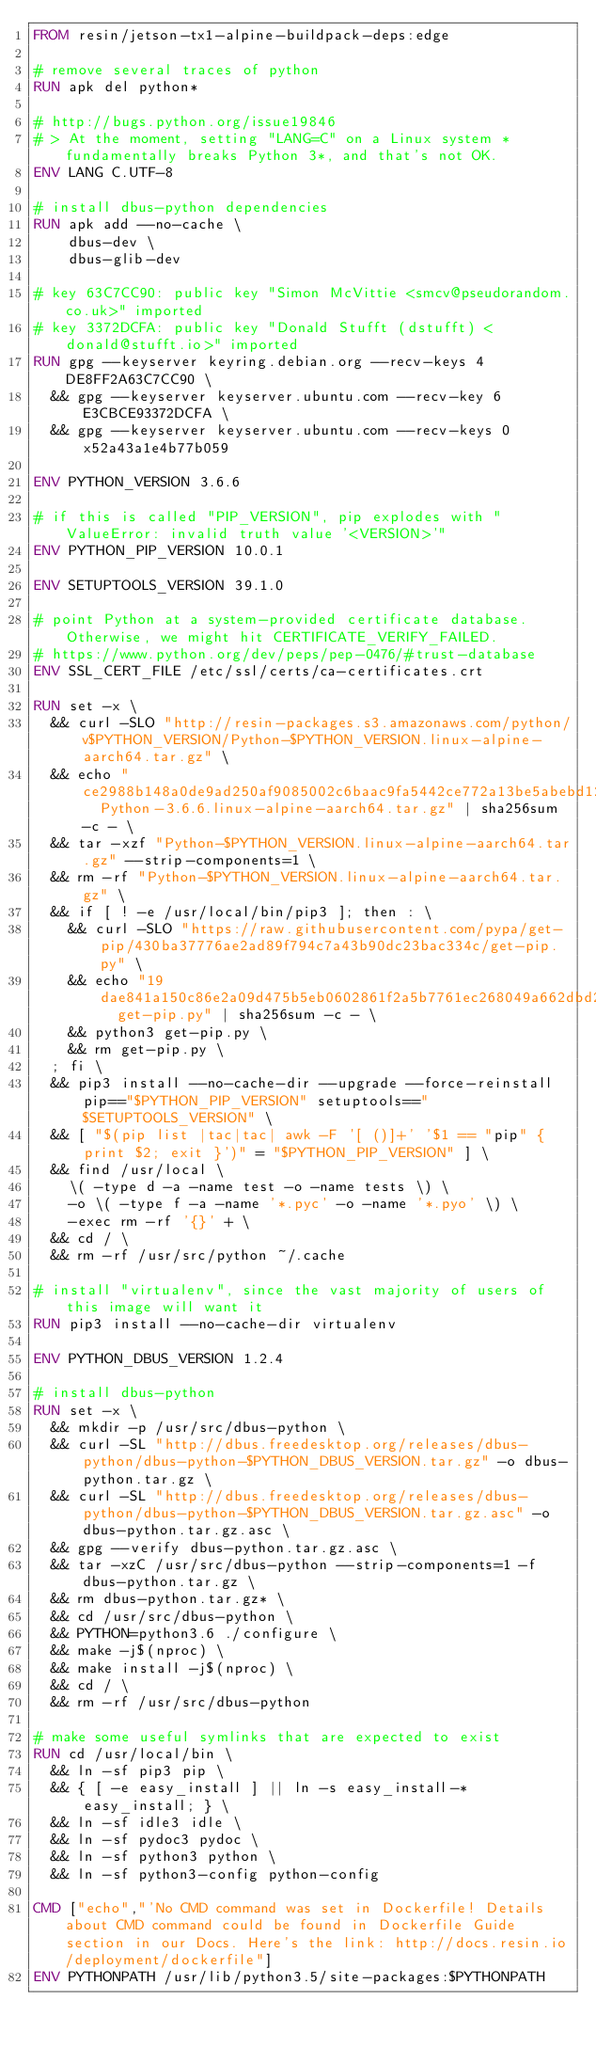Convert code to text. <code><loc_0><loc_0><loc_500><loc_500><_Dockerfile_>FROM resin/jetson-tx1-alpine-buildpack-deps:edge

# remove several traces of python
RUN apk del python*

# http://bugs.python.org/issue19846
# > At the moment, setting "LANG=C" on a Linux system *fundamentally breaks Python 3*, and that's not OK.
ENV LANG C.UTF-8

# install dbus-python dependencies 
RUN apk add --no-cache \
		dbus-dev \
		dbus-glib-dev

# key 63C7CC90: public key "Simon McVittie <smcv@pseudorandom.co.uk>" imported
# key 3372DCFA: public key "Donald Stufft (dstufft) <donald@stufft.io>" imported
RUN gpg --keyserver keyring.debian.org --recv-keys 4DE8FF2A63C7CC90 \
	&& gpg --keyserver keyserver.ubuntu.com --recv-key 6E3CBCE93372DCFA \
	&& gpg --keyserver keyserver.ubuntu.com --recv-keys 0x52a43a1e4b77b059

ENV PYTHON_VERSION 3.6.6

# if this is called "PIP_VERSION", pip explodes with "ValueError: invalid truth value '<VERSION>'"
ENV PYTHON_PIP_VERSION 10.0.1

ENV SETUPTOOLS_VERSION 39.1.0

# point Python at a system-provided certificate database. Otherwise, we might hit CERTIFICATE_VERIFY_FAILED.
# https://www.python.org/dev/peps/pep-0476/#trust-database
ENV SSL_CERT_FILE /etc/ssl/certs/ca-certificates.crt

RUN set -x \
	&& curl -SLO "http://resin-packages.s3.amazonaws.com/python/v$PYTHON_VERSION/Python-$PYTHON_VERSION.linux-alpine-aarch64.tar.gz" \
	&& echo "ce2988b148a0de9ad250af9085002c6baac9fa5442ce772a13be5abebd12aee4  Python-3.6.6.linux-alpine-aarch64.tar.gz" | sha256sum -c - \
	&& tar -xzf "Python-$PYTHON_VERSION.linux-alpine-aarch64.tar.gz" --strip-components=1 \
	&& rm -rf "Python-$PYTHON_VERSION.linux-alpine-aarch64.tar.gz" \
	&& if [ ! -e /usr/local/bin/pip3 ]; then : \
		&& curl -SLO "https://raw.githubusercontent.com/pypa/get-pip/430ba37776ae2ad89f794c7a43b90dc23bac334c/get-pip.py" \
		&& echo "19dae841a150c86e2a09d475b5eb0602861f2a5b7761ec268049a662dbd2bd0c  get-pip.py" | sha256sum -c - \
		&& python3 get-pip.py \
		&& rm get-pip.py \
	; fi \
	&& pip3 install --no-cache-dir --upgrade --force-reinstall pip=="$PYTHON_PIP_VERSION" setuptools=="$SETUPTOOLS_VERSION" \
	&& [ "$(pip list |tac|tac| awk -F '[ ()]+' '$1 == "pip" { print $2; exit }')" = "$PYTHON_PIP_VERSION" ] \
	&& find /usr/local \
		\( -type d -a -name test -o -name tests \) \
		-o \( -type f -a -name '*.pyc' -o -name '*.pyo' \) \
		-exec rm -rf '{}' + \
	&& cd / \
	&& rm -rf /usr/src/python ~/.cache

# install "virtualenv", since the vast majority of users of this image will want it
RUN pip3 install --no-cache-dir virtualenv

ENV PYTHON_DBUS_VERSION 1.2.4

# install dbus-python
RUN set -x \
	&& mkdir -p /usr/src/dbus-python \
	&& curl -SL "http://dbus.freedesktop.org/releases/dbus-python/dbus-python-$PYTHON_DBUS_VERSION.tar.gz" -o dbus-python.tar.gz \
	&& curl -SL "http://dbus.freedesktop.org/releases/dbus-python/dbus-python-$PYTHON_DBUS_VERSION.tar.gz.asc" -o dbus-python.tar.gz.asc \
	&& gpg --verify dbus-python.tar.gz.asc \
	&& tar -xzC /usr/src/dbus-python --strip-components=1 -f dbus-python.tar.gz \
	&& rm dbus-python.tar.gz* \
	&& cd /usr/src/dbus-python \
	&& PYTHON=python3.6 ./configure \
	&& make -j$(nproc) \
	&& make install -j$(nproc) \
	&& cd / \
	&& rm -rf /usr/src/dbus-python

# make some useful symlinks that are expected to exist
RUN cd /usr/local/bin \
	&& ln -sf pip3 pip \
	&& { [ -e easy_install ] || ln -s easy_install-* easy_install; } \
	&& ln -sf idle3 idle \
	&& ln -sf pydoc3 pydoc \
	&& ln -sf python3 python \
	&& ln -sf python3-config python-config

CMD ["echo","'No CMD command was set in Dockerfile! Details about CMD command could be found in Dockerfile Guide section in our Docs. Here's the link: http://docs.resin.io/deployment/dockerfile"]
ENV PYTHONPATH /usr/lib/python3.5/site-packages:$PYTHONPATH
</code> 